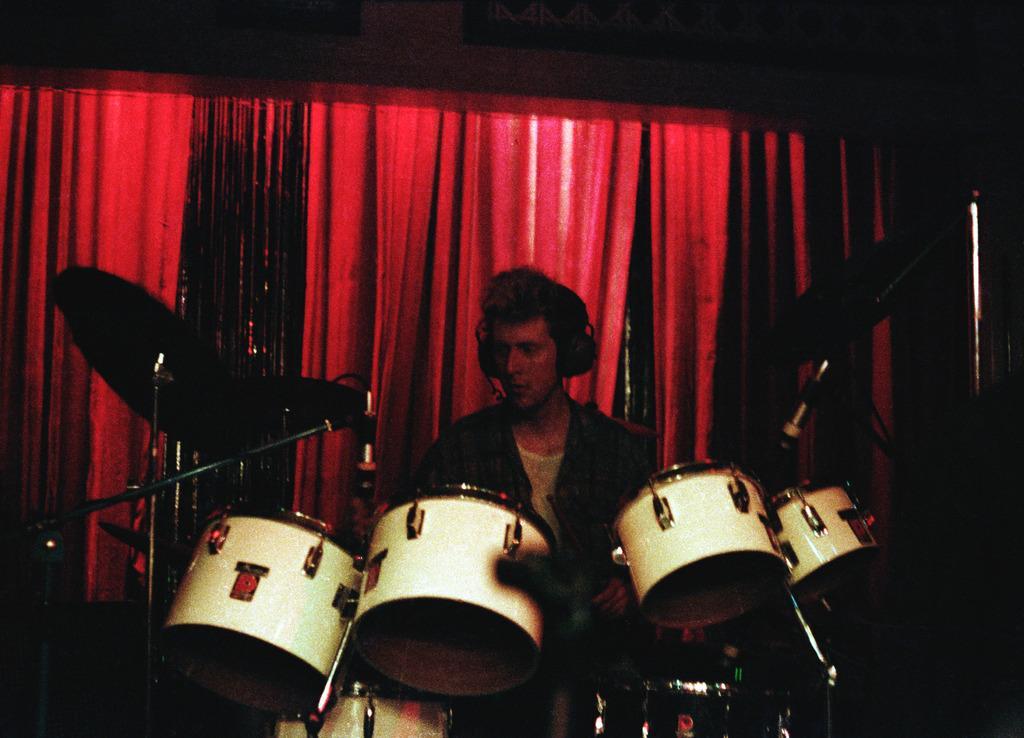Can you describe this image briefly? In this image we can see a person playing musical instrument. In the background of the image there is a red color cloth. 